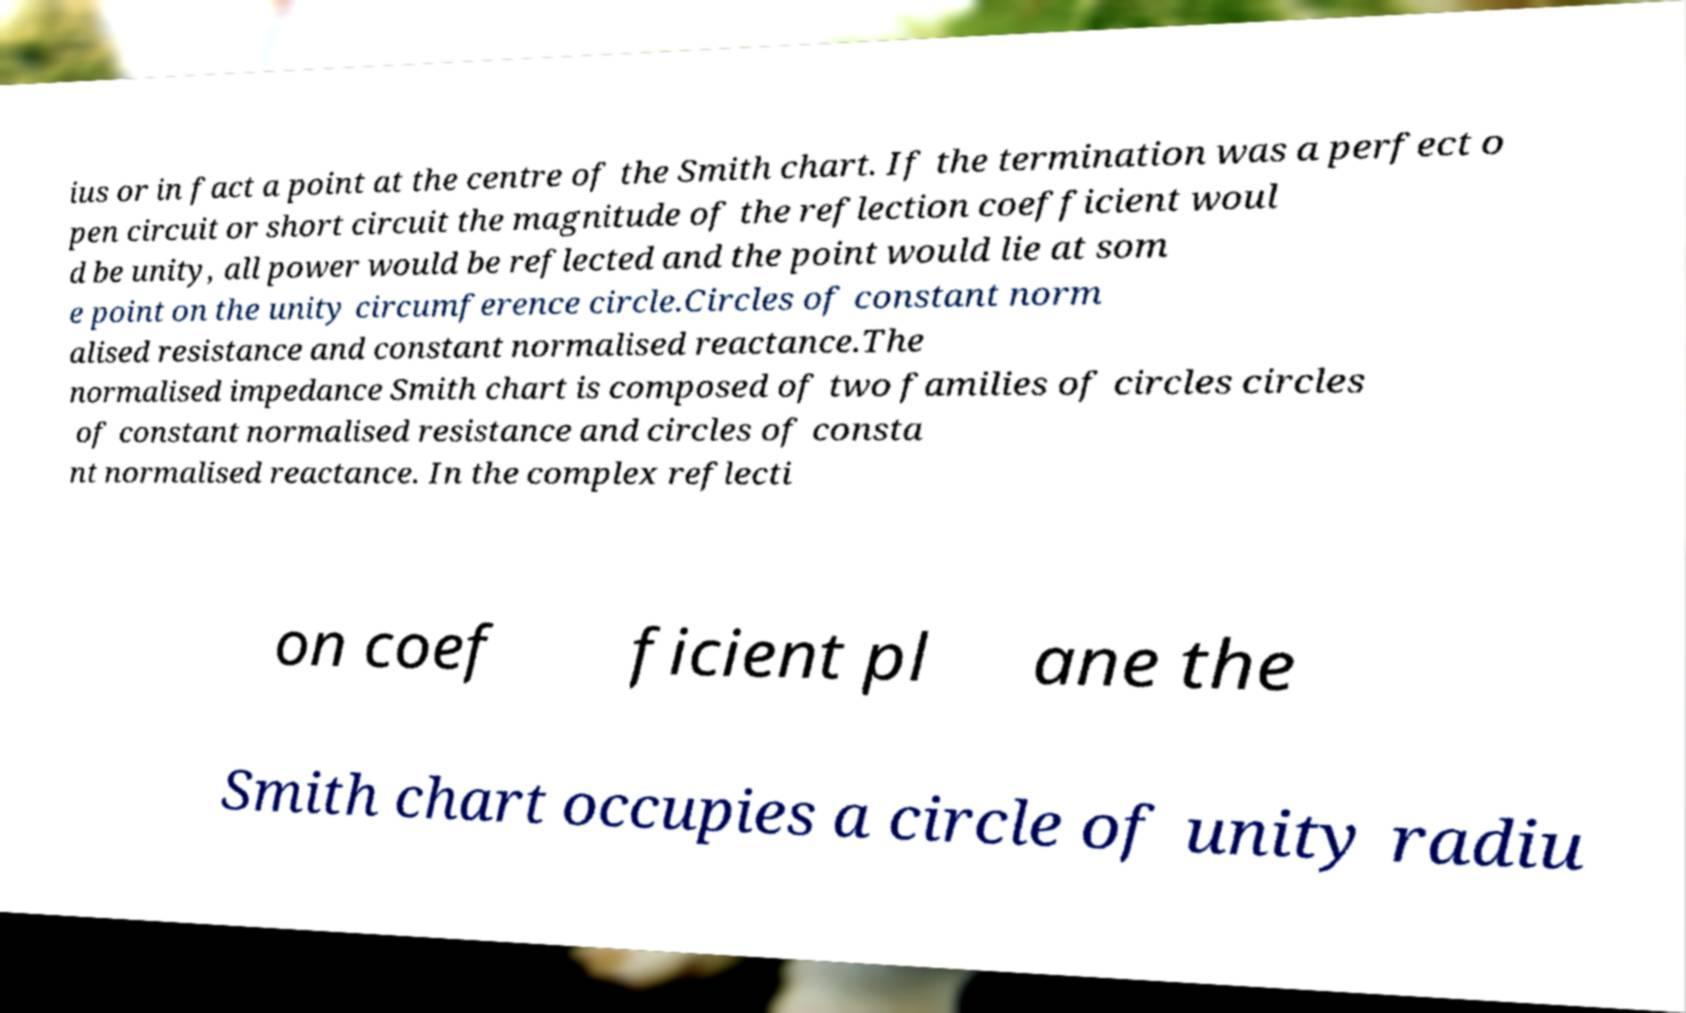Could you extract and type out the text from this image? ius or in fact a point at the centre of the Smith chart. If the termination was a perfect o pen circuit or short circuit the magnitude of the reflection coefficient woul d be unity, all power would be reflected and the point would lie at som e point on the unity circumference circle.Circles of constant norm alised resistance and constant normalised reactance.The normalised impedance Smith chart is composed of two families of circles circles of constant normalised resistance and circles of consta nt normalised reactance. In the complex reflecti on coef ficient pl ane the Smith chart occupies a circle of unity radiu 